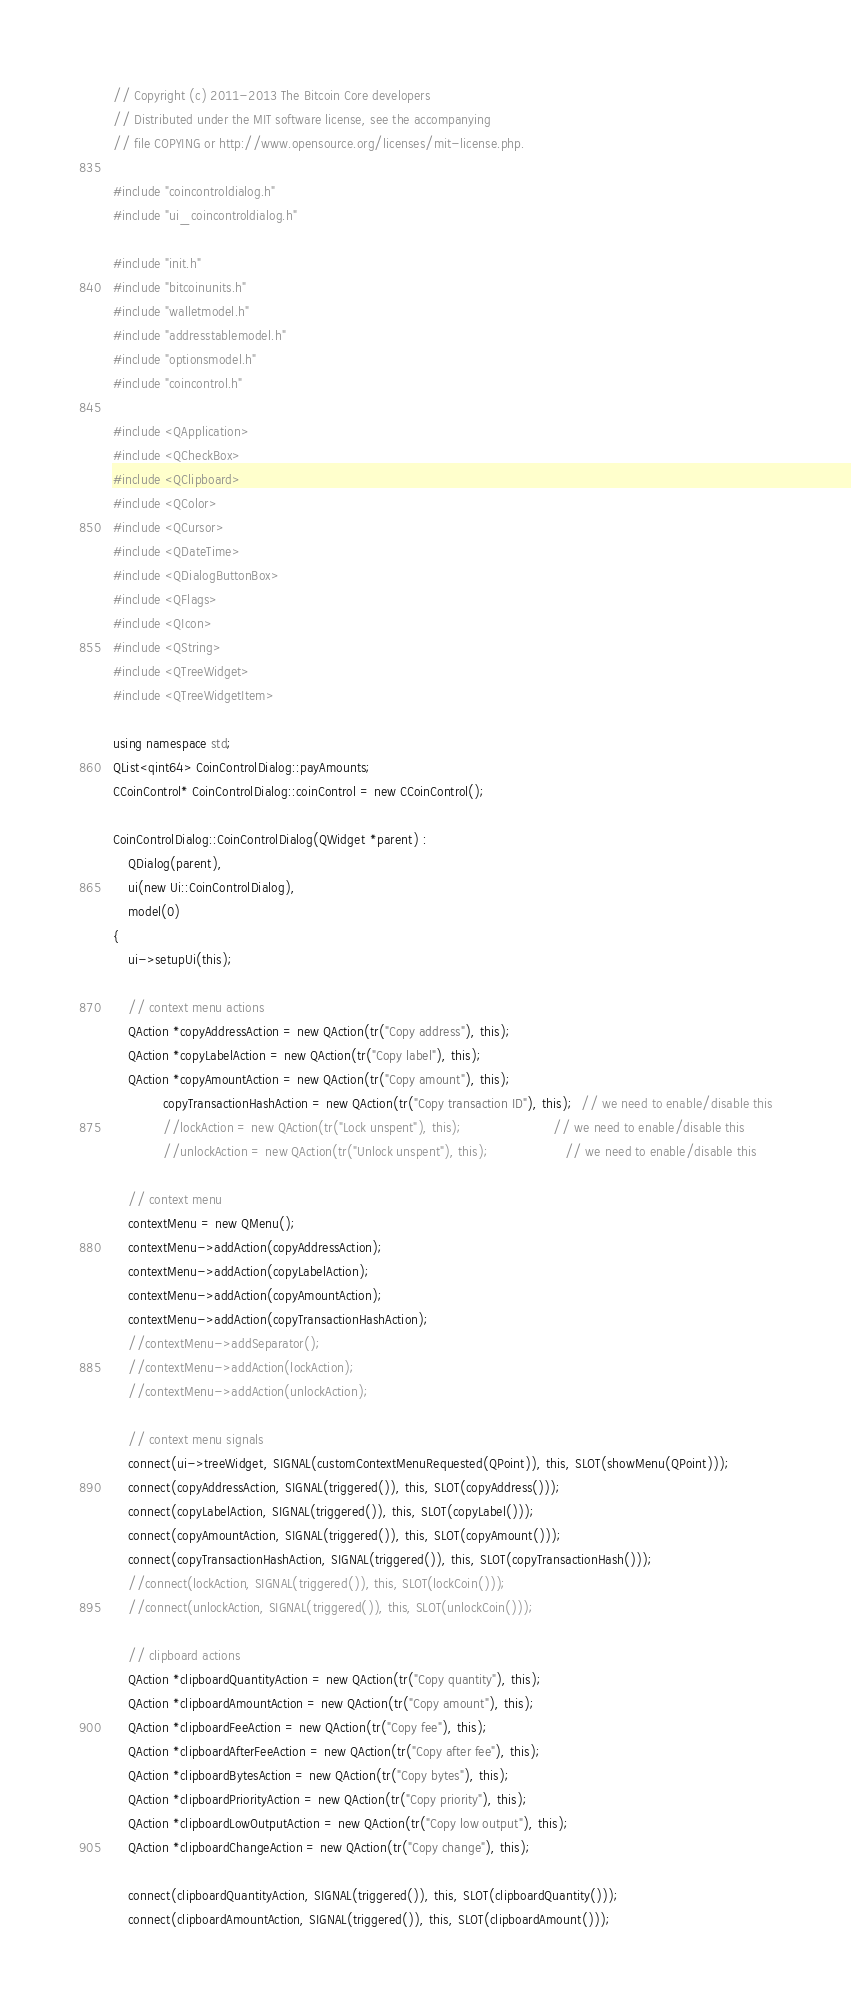<code> <loc_0><loc_0><loc_500><loc_500><_C++_>// Copyright (c) 2011-2013 The Bitcoin Core developers
// Distributed under the MIT software license, see the accompanying
// file COPYING or http://www.opensource.org/licenses/mit-license.php.

#include "coincontroldialog.h"
#include "ui_coincontroldialog.h"

#include "init.h"
#include "bitcoinunits.h"
#include "walletmodel.h"
#include "addresstablemodel.h"
#include "optionsmodel.h"
#include "coincontrol.h"

#include <QApplication>
#include <QCheckBox>
#include <QClipboard>
#include <QColor>
#include <QCursor>
#include <QDateTime>
#include <QDialogButtonBox>
#include <QFlags>
#include <QIcon>
#include <QString>
#include <QTreeWidget>
#include <QTreeWidgetItem>

using namespace std;
QList<qint64> CoinControlDialog::payAmounts;
CCoinControl* CoinControlDialog::coinControl = new CCoinControl();

CoinControlDialog::CoinControlDialog(QWidget *parent) :
    QDialog(parent),
    ui(new Ui::CoinControlDialog),
    model(0)
{
    ui->setupUi(this);

    // context menu actions
    QAction *copyAddressAction = new QAction(tr("Copy address"), this);
    QAction *copyLabelAction = new QAction(tr("Copy label"), this);
    QAction *copyAmountAction = new QAction(tr("Copy amount"), this);
             copyTransactionHashAction = new QAction(tr("Copy transaction ID"), this);  // we need to enable/disable this
             //lockAction = new QAction(tr("Lock unspent"), this);                        // we need to enable/disable this
             //unlockAction = new QAction(tr("Unlock unspent"), this);                    // we need to enable/disable this

    // context menu
    contextMenu = new QMenu();
    contextMenu->addAction(copyAddressAction);
    contextMenu->addAction(copyLabelAction);
    contextMenu->addAction(copyAmountAction);
    contextMenu->addAction(copyTransactionHashAction);
    //contextMenu->addSeparator();
    //contextMenu->addAction(lockAction);
    //contextMenu->addAction(unlockAction);

    // context menu signals
    connect(ui->treeWidget, SIGNAL(customContextMenuRequested(QPoint)), this, SLOT(showMenu(QPoint)));
    connect(copyAddressAction, SIGNAL(triggered()), this, SLOT(copyAddress()));
    connect(copyLabelAction, SIGNAL(triggered()), this, SLOT(copyLabel()));
    connect(copyAmountAction, SIGNAL(triggered()), this, SLOT(copyAmount()));
    connect(copyTransactionHashAction, SIGNAL(triggered()), this, SLOT(copyTransactionHash()));
    //connect(lockAction, SIGNAL(triggered()), this, SLOT(lockCoin()));
    //connect(unlockAction, SIGNAL(triggered()), this, SLOT(unlockCoin()));

    // clipboard actions
    QAction *clipboardQuantityAction = new QAction(tr("Copy quantity"), this);
    QAction *clipboardAmountAction = new QAction(tr("Copy amount"), this);
    QAction *clipboardFeeAction = new QAction(tr("Copy fee"), this);
    QAction *clipboardAfterFeeAction = new QAction(tr("Copy after fee"), this);
    QAction *clipboardBytesAction = new QAction(tr("Copy bytes"), this);
    QAction *clipboardPriorityAction = new QAction(tr("Copy priority"), this);
    QAction *clipboardLowOutputAction = new QAction(tr("Copy low output"), this);
    QAction *clipboardChangeAction = new QAction(tr("Copy change"), this);

    connect(clipboardQuantityAction, SIGNAL(triggered()), this, SLOT(clipboardQuantity()));
    connect(clipboardAmountAction, SIGNAL(triggered()), this, SLOT(clipboardAmount()));</code> 